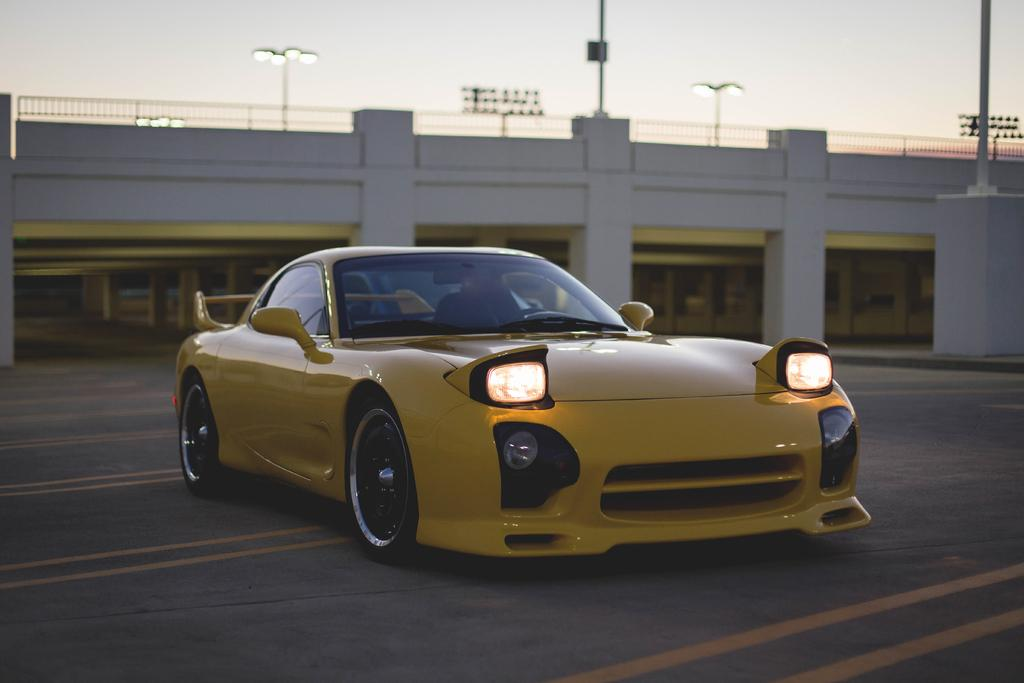What is the main subject of the image? There is a car on the road in the image. What structures can be seen in the image? There are pillars, a fence, lights, and poles in the image. What is visible in the background of the image? The sky is visible in the background of the image. What type of cheese is being used to decorate the downtown area in the image? There is no cheese or downtown area present in the image. What flavor of soda is being advertised on the car in the image? There is no soda or advertisement visible on the car in the image. 